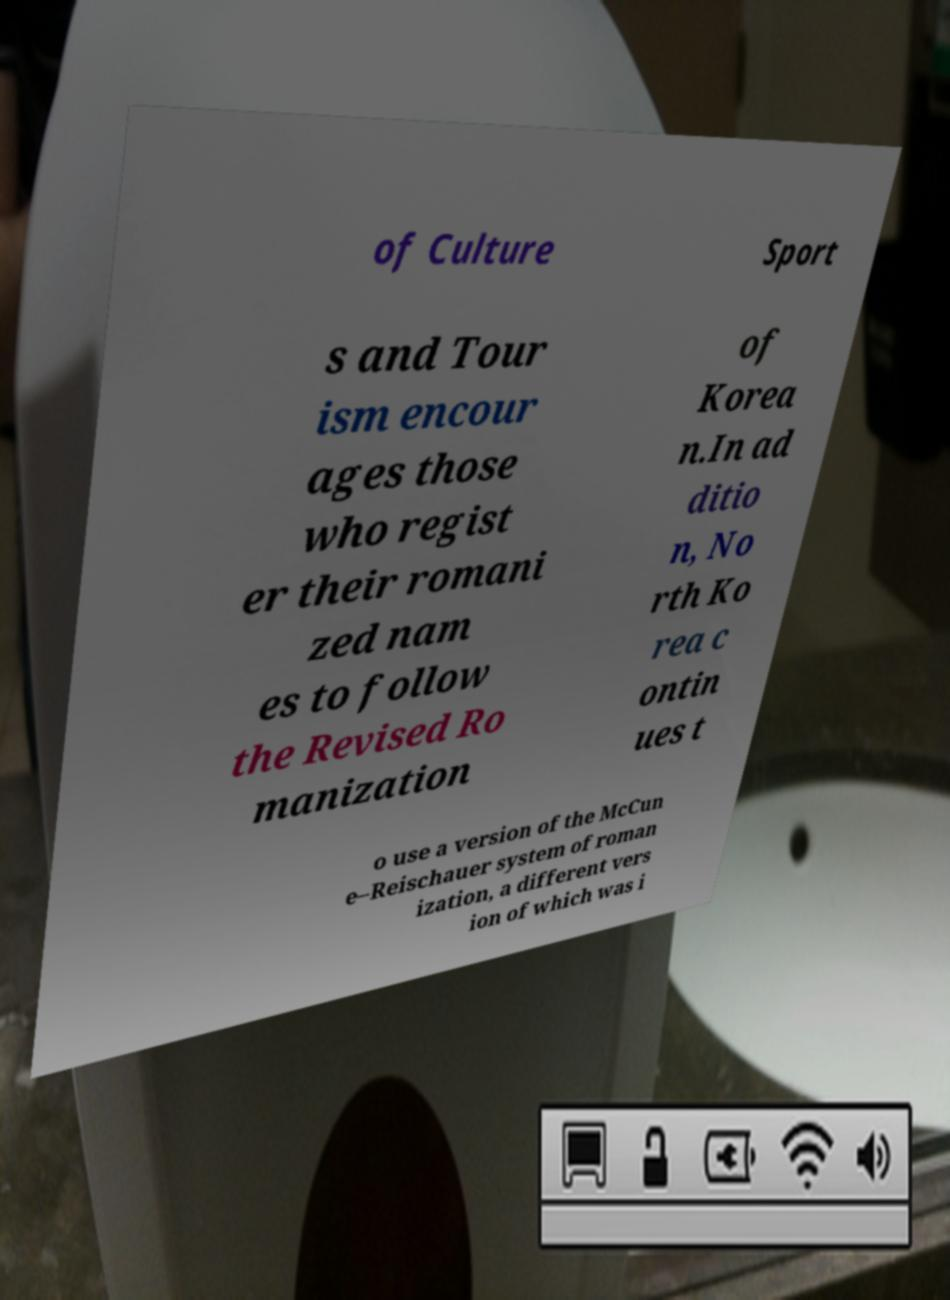For documentation purposes, I need the text within this image transcribed. Could you provide that? of Culture Sport s and Tour ism encour ages those who regist er their romani zed nam es to follow the Revised Ro manization of Korea n.In ad ditio n, No rth Ko rea c ontin ues t o use a version of the McCun e–Reischauer system of roman ization, a different vers ion of which was i 